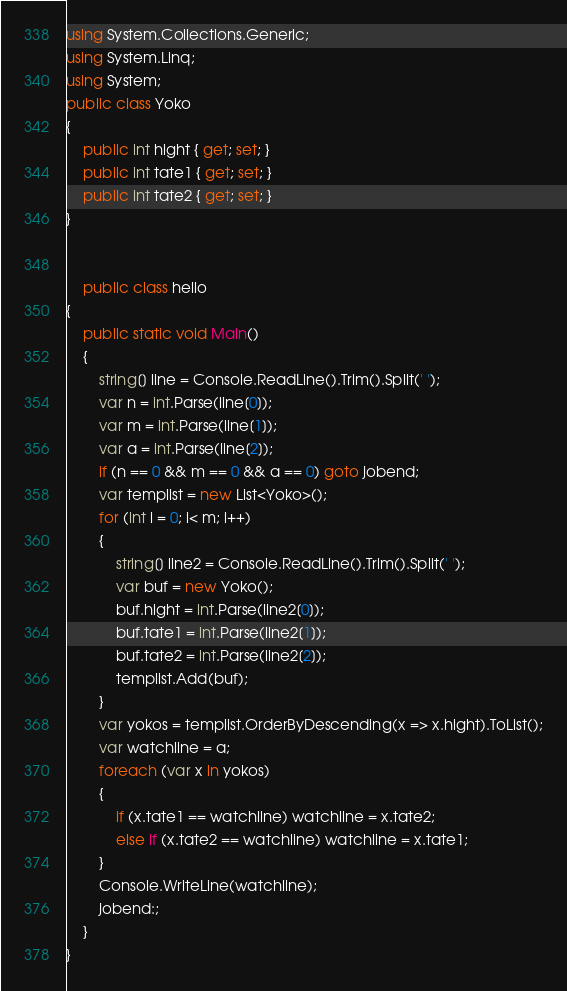Convert code to text. <code><loc_0><loc_0><loc_500><loc_500><_C#_>using System.Collections.Generic;
using System.Linq;
using System;
public class Yoko
{
    public int hight { get; set; }
    public int tate1 { get; set; }
    public int tate2 { get; set; }
}
    
    
    public class hello
{
    public static void Main()
    {
        string[] line = Console.ReadLine().Trim().Split(' ');
        var n = int.Parse(line[0]);
        var m = int.Parse(line[1]);
        var a = int.Parse(line[2]);
        if (n == 0 && m == 0 && a == 0) goto jobend;
        var templist = new List<Yoko>();
        for (int i = 0; i< m; i++)
        {
            string[] line2 = Console.ReadLine().Trim().Split(' ');
            var buf = new Yoko();
            buf.hight = int.Parse(line2[0]);
            buf.tate1 = int.Parse(line2[1]);
            buf.tate2 = int.Parse(line2[2]);
            templist.Add(buf);
        }
        var yokos = templist.OrderByDescending(x => x.hight).ToList();
        var watchline = a;
        foreach (var x in yokos)
        {
            if (x.tate1 == watchline) watchline = x.tate2;
            else if (x.tate2 == watchline) watchline = x.tate1;
        }
        Console.WriteLine(watchline);
        jobend:;
    }
}</code> 